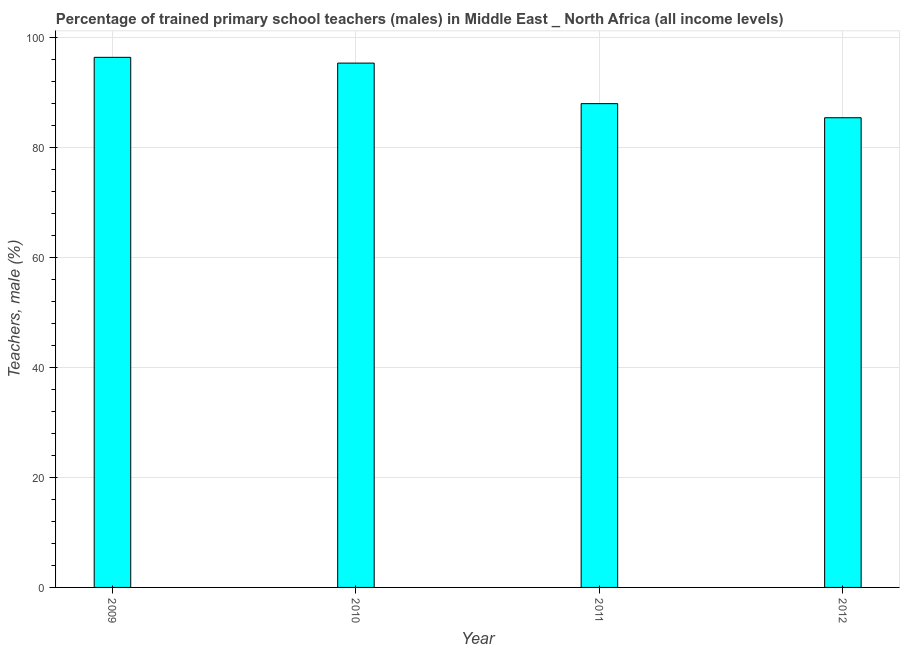Does the graph contain grids?
Make the answer very short. Yes. What is the title of the graph?
Offer a terse response. Percentage of trained primary school teachers (males) in Middle East _ North Africa (all income levels). What is the label or title of the Y-axis?
Give a very brief answer. Teachers, male (%). What is the percentage of trained male teachers in 2011?
Give a very brief answer. 87.91. Across all years, what is the maximum percentage of trained male teachers?
Ensure brevity in your answer.  96.33. Across all years, what is the minimum percentage of trained male teachers?
Offer a terse response. 85.35. In which year was the percentage of trained male teachers minimum?
Your response must be concise. 2012. What is the sum of the percentage of trained male teachers?
Provide a succinct answer. 364.88. What is the difference between the percentage of trained male teachers in 2010 and 2011?
Make the answer very short. 7.37. What is the average percentage of trained male teachers per year?
Give a very brief answer. 91.22. What is the median percentage of trained male teachers?
Make the answer very short. 91.6. What is the ratio of the percentage of trained male teachers in 2010 to that in 2012?
Offer a very short reply. 1.12. Is the percentage of trained male teachers in 2011 less than that in 2012?
Give a very brief answer. No. What is the difference between the highest and the lowest percentage of trained male teachers?
Your answer should be very brief. 10.98. In how many years, is the percentage of trained male teachers greater than the average percentage of trained male teachers taken over all years?
Your answer should be compact. 2. How many bars are there?
Make the answer very short. 4. What is the difference between two consecutive major ticks on the Y-axis?
Offer a terse response. 20. Are the values on the major ticks of Y-axis written in scientific E-notation?
Offer a terse response. No. What is the Teachers, male (%) in 2009?
Your answer should be compact. 96.33. What is the Teachers, male (%) of 2010?
Offer a very short reply. 95.28. What is the Teachers, male (%) of 2011?
Your answer should be very brief. 87.91. What is the Teachers, male (%) of 2012?
Make the answer very short. 85.35. What is the difference between the Teachers, male (%) in 2009 and 2010?
Make the answer very short. 1.05. What is the difference between the Teachers, male (%) in 2009 and 2011?
Provide a short and direct response. 8.42. What is the difference between the Teachers, male (%) in 2009 and 2012?
Make the answer very short. 10.98. What is the difference between the Teachers, male (%) in 2010 and 2011?
Your answer should be compact. 7.37. What is the difference between the Teachers, male (%) in 2010 and 2012?
Offer a very short reply. 9.93. What is the difference between the Teachers, male (%) in 2011 and 2012?
Your answer should be very brief. 2.56. What is the ratio of the Teachers, male (%) in 2009 to that in 2010?
Make the answer very short. 1.01. What is the ratio of the Teachers, male (%) in 2009 to that in 2011?
Your response must be concise. 1.1. What is the ratio of the Teachers, male (%) in 2009 to that in 2012?
Provide a short and direct response. 1.13. What is the ratio of the Teachers, male (%) in 2010 to that in 2011?
Ensure brevity in your answer.  1.08. What is the ratio of the Teachers, male (%) in 2010 to that in 2012?
Give a very brief answer. 1.12. 